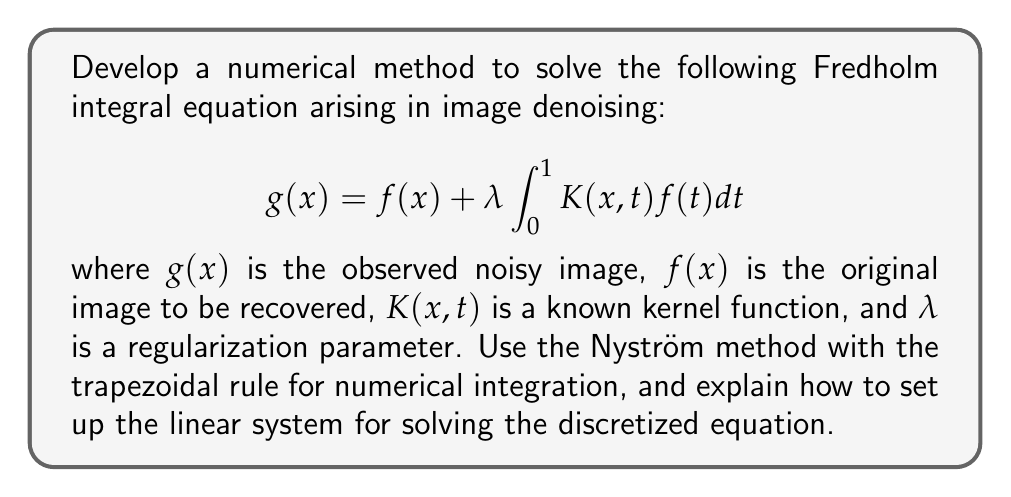Provide a solution to this math problem. To solve this Fredholm integral equation numerically using the Nyström method with the trapezoidal rule, we follow these steps:

1. Discretize the interval $[0,1]$ into $n$ equally spaced points:
   $x_i = \frac{i-1}{n-1}$, for $i = 1, 2, ..., n$

2. Apply the trapezoidal rule to approximate the integral:
   $$\int_0^1 K(x,t)f(t)dt \approx \frac{1}{2(n-1)} \sum_{j=1}^n w_j K(x,x_j)f(x_j)$$
   where $w_1 = w_n = 1$ and $w_j = 2$ for $j = 2, 3, ..., n-1$

3. Substitute the approximation into the original equation:
   $$g(x_i) \approx f(x_i) + \frac{\lambda}{2(n-1)} \sum_{j=1}^n w_j K(x_i,x_j)f(x_j)$$

4. Define the matrices and vectors:
   $\mathbf{g} = [g(x_1), ..., g(x_n)]^T$
   $\mathbf{f} = [f(x_1), ..., f(x_n)]^T$
   $\mathbf{K}_{ij} = K(x_i, x_j)$
   $\mathbf{W} = \text{diag}(w_1, ..., w_n)$

5. Set up the linear system:
   $$\mathbf{g} = \mathbf{f} + \frac{\lambda}{2(n-1)} \mathbf{K} \mathbf{W} \mathbf{f}$$

6. Rearrange to standard form $\mathbf{A}\mathbf{f} = \mathbf{g}$:
   $$(\mathbf{I} - \frac{\lambda}{2(n-1)} \mathbf{K} \mathbf{W}) \mathbf{f} = \mathbf{g}$$

7. Solve the linear system using an appropriate method (e.g., Gaussian elimination, iterative methods) to obtain the approximate solution $\mathbf{f}$.

This method provides a discrete approximation of the original image $f(x)$ at the chosen points $x_i$.
Answer: Nyström method with trapezoidal rule: $(\mathbf{I} - \frac{\lambda}{2(n-1)} \mathbf{K} \mathbf{W}) \mathbf{f} = \mathbf{g}$ 